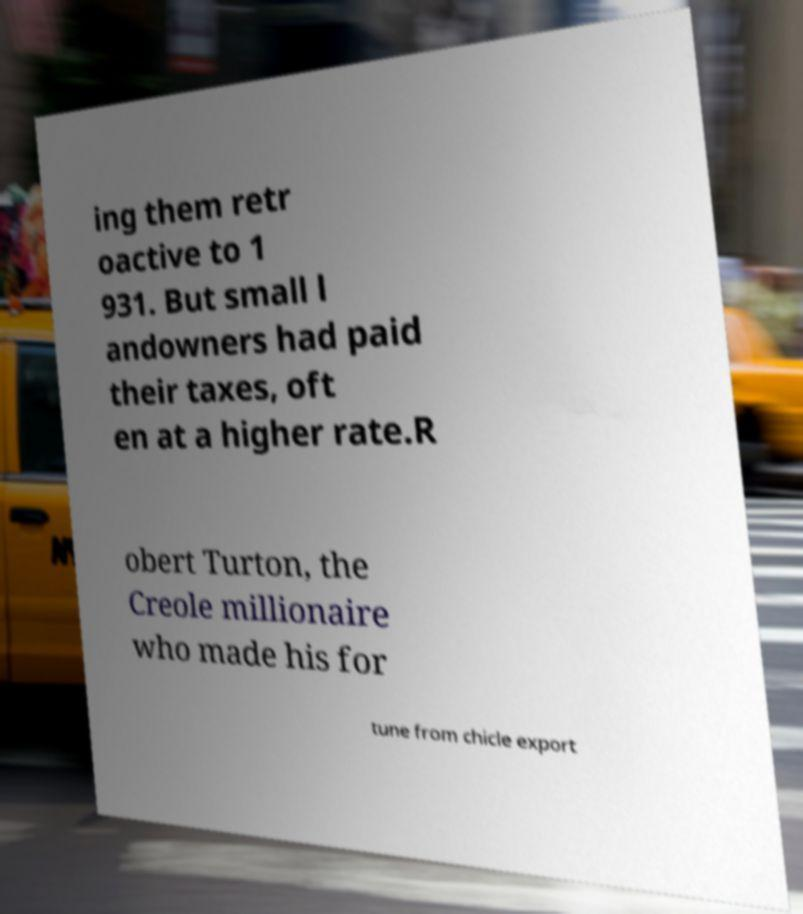Please identify and transcribe the text found in this image. ing them retr oactive to 1 931. But small l andowners had paid their taxes, oft en at a higher rate.R obert Turton, the Creole millionaire who made his for tune from chicle export 